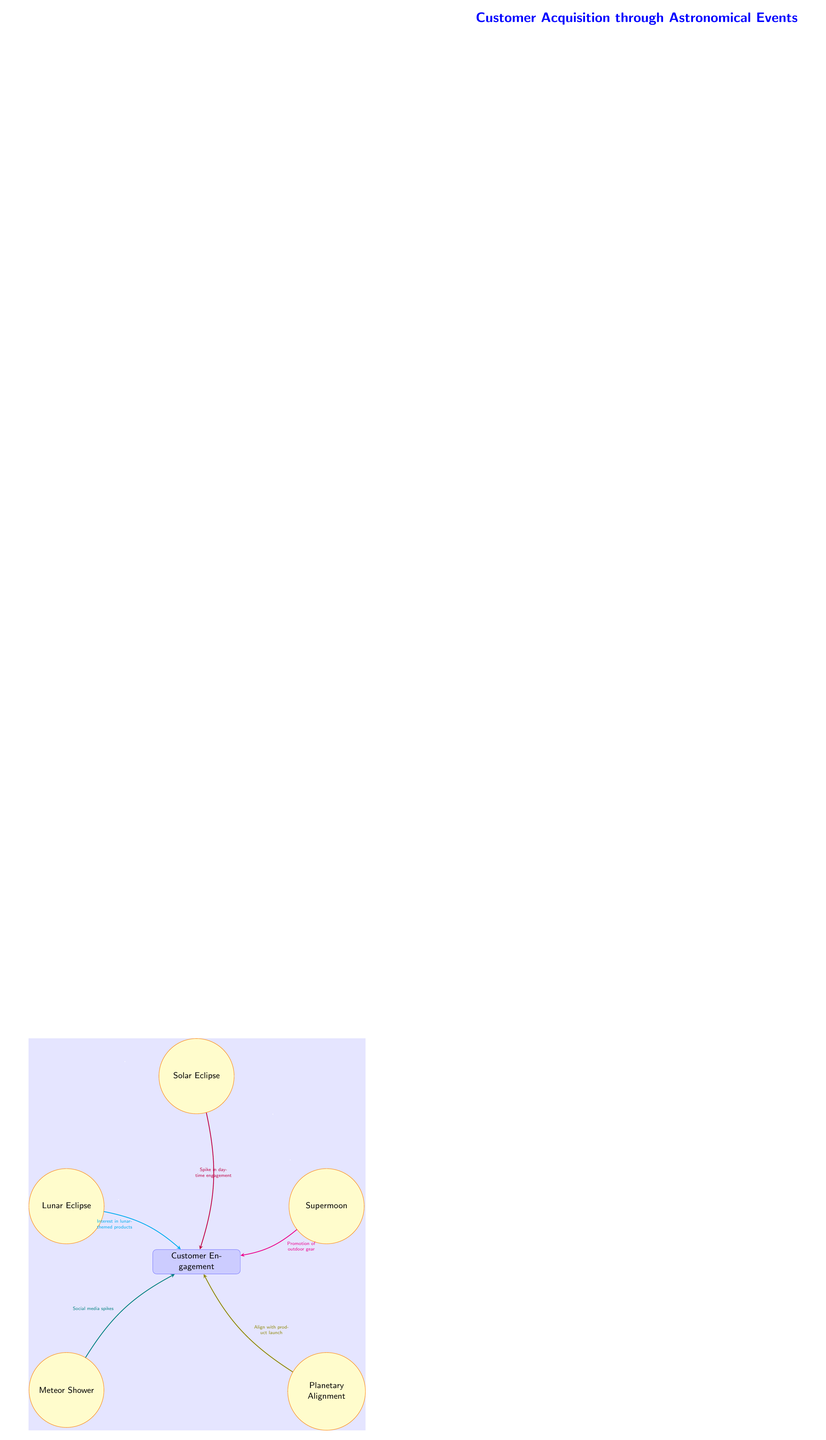What are the celestial events in the diagram? The diagram lists five celestial events: Solar Eclipse, Lunar Eclipse, Supermoon, Meteor Shower, and Planetary Alignment.
Answer: Solar Eclipse, Lunar Eclipse, Supermoon, Meteor Shower, Planetary Alignment Which celestial event is represented at the top? The Solar Eclipse is the highest event in the diagram, indicating that it is the primary focus for customer engagement.
Answer: Solar Eclipse What type of product interest is associated with the Lunar Eclipse? The arrow connecting Lunar Eclipse to Customer Engagement specifies "Interest in lunar-themed products," indicating a direct effect on customer behavior.
Answer: Interest in lunar-themed products How many arrows indicate a connection to customer engagement? There are five arrows pointing towards the Customer Engagement node, each representing a different event contributing to customer interaction.
Answer: Five Which event promotes outdoor gear? The Supermoon event is labeled with "Promotion of outdoor gear," indicating the specific engagement strategy linked to this astronomical occurrence.
Answer: Promotion of outdoor gear What color represents the connection from the Planetary Alignment? The connection from the Planetary Alignment is represented by an olive-colored arrow, which visually differentiates it from others in the diagram.
Answer: Olive Why is there a spike in daytime engagement? The Solar Eclipse event is directly linked to "Spike in daytime engagement," showing its significance in capturing customer attention at that time.
Answer: Spike in daytime engagement What is the nature of engagement during the Meteor Shower? The arrow from the Meteor Shower event states "Social media spikes," suggesting that this event triggers increased online interaction and engagement.
Answer: Social media spikes How does the diagram represent customer engagement? Customer engagement is represented by a rectangular node positioned below the celestial events, indicating the cumulative impact of these events on customer interaction.
Answer: Customer Engagement 